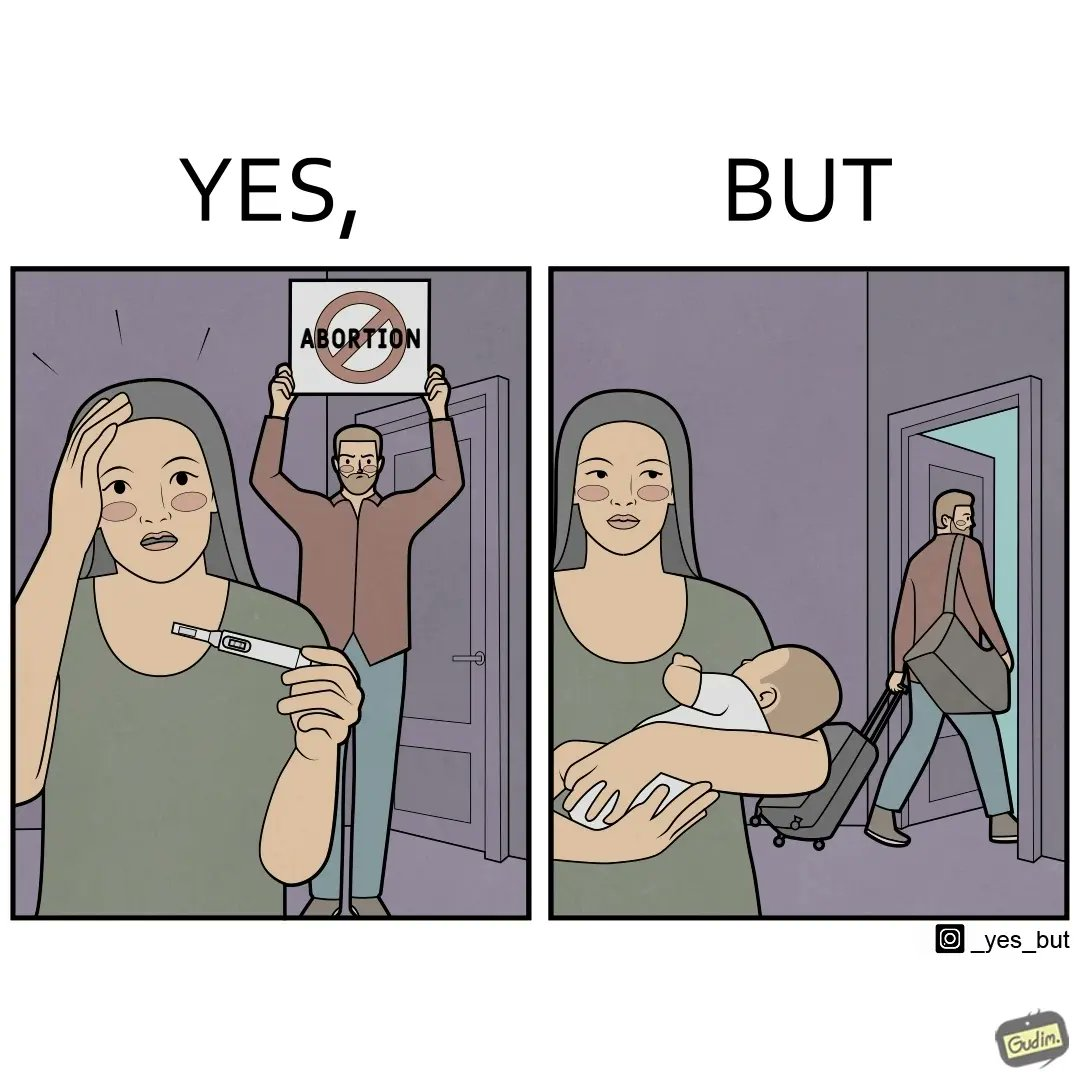Provide a description of this image. The images are ironic, since they show how men protest against abortion of babies but they choose to leave instead of taking care of the babies once they are born leaving the mother with neither a choice or support for raising a child 